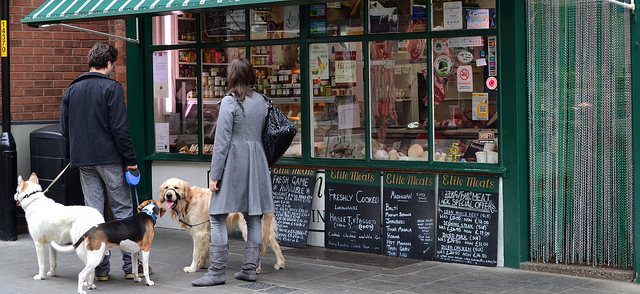Describe the setting of the image. The image shows a sidewalk in front of a shop, which appears to be a butcher's store called 'Edible Meats' given the signage. There are chalkboards displaying various products for sale, suggesting this is a place where fresh meat is available. People with dogs are standing in front of the store, possibly suggesting that the area is pet-friendly or they are waiting for someone inside. 
What can you tell about the behavior of the people and dogs? The people seem to be engaged in casual, everyday activities, possibly waiting or looking at the display of the meat shop. The dogs are on leashes, indicating that they are well-managed by their owners. They appear to be calm and not showing signs of distress, which might suggest they are used to the urban environment and being around other dogs and people. 